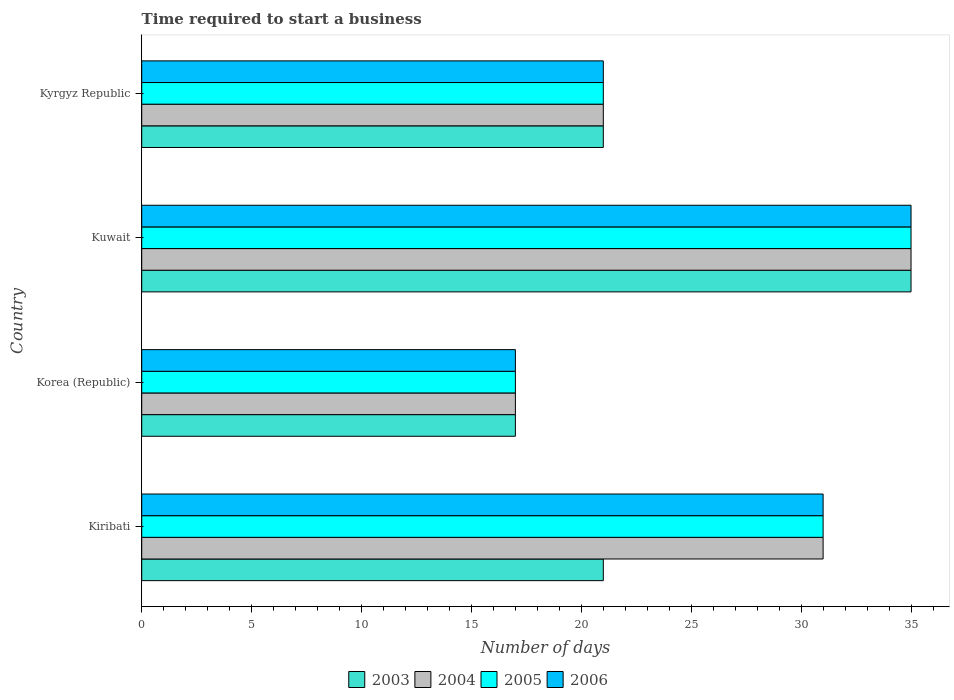How many different coloured bars are there?
Give a very brief answer. 4. In how many cases, is the number of bars for a given country not equal to the number of legend labels?
Make the answer very short. 0. What is the number of days required to start a business in 2004 in Korea (Republic)?
Offer a terse response. 17. Across all countries, what is the minimum number of days required to start a business in 2005?
Provide a succinct answer. 17. In which country was the number of days required to start a business in 2003 maximum?
Your response must be concise. Kuwait. In which country was the number of days required to start a business in 2005 minimum?
Your response must be concise. Korea (Republic). What is the total number of days required to start a business in 2003 in the graph?
Make the answer very short. 94. What is the average number of days required to start a business in 2004 per country?
Keep it short and to the point. 26. What is the difference between the number of days required to start a business in 2004 and number of days required to start a business in 2005 in Kyrgyz Republic?
Offer a terse response. 0. In how many countries, is the number of days required to start a business in 2003 greater than 9 days?
Your response must be concise. 4. What is the ratio of the number of days required to start a business in 2004 in Kiribati to that in Korea (Republic)?
Offer a very short reply. 1.82. What is the difference between the highest and the lowest number of days required to start a business in 2003?
Keep it short and to the point. 18. In how many countries, is the number of days required to start a business in 2005 greater than the average number of days required to start a business in 2005 taken over all countries?
Your answer should be very brief. 2. What does the 2nd bar from the top in Kiribati represents?
Offer a very short reply. 2005. What does the 2nd bar from the bottom in Korea (Republic) represents?
Provide a succinct answer. 2004. How many bars are there?
Your answer should be very brief. 16. How many countries are there in the graph?
Provide a short and direct response. 4. What is the difference between two consecutive major ticks on the X-axis?
Provide a short and direct response. 5. Does the graph contain grids?
Your response must be concise. No. What is the title of the graph?
Give a very brief answer. Time required to start a business. What is the label or title of the X-axis?
Your answer should be compact. Number of days. What is the label or title of the Y-axis?
Give a very brief answer. Country. What is the Number of days of 2004 in Kiribati?
Give a very brief answer. 31. What is the Number of days of 2005 in Kiribati?
Provide a short and direct response. 31. What is the Number of days of 2006 in Kiribati?
Provide a short and direct response. 31. What is the Number of days of 2004 in Korea (Republic)?
Your response must be concise. 17. What is the Number of days of 2006 in Korea (Republic)?
Provide a succinct answer. 17. What is the Number of days in 2003 in Kuwait?
Provide a short and direct response. 35. What is the Number of days in 2005 in Kuwait?
Make the answer very short. 35. What is the Number of days of 2004 in Kyrgyz Republic?
Keep it short and to the point. 21. What is the Number of days of 2006 in Kyrgyz Republic?
Ensure brevity in your answer.  21. Across all countries, what is the maximum Number of days in 2003?
Provide a succinct answer. 35. Across all countries, what is the maximum Number of days in 2005?
Make the answer very short. 35. Across all countries, what is the maximum Number of days of 2006?
Provide a succinct answer. 35. Across all countries, what is the minimum Number of days in 2004?
Offer a very short reply. 17. What is the total Number of days in 2003 in the graph?
Ensure brevity in your answer.  94. What is the total Number of days of 2004 in the graph?
Keep it short and to the point. 104. What is the total Number of days of 2005 in the graph?
Ensure brevity in your answer.  104. What is the total Number of days of 2006 in the graph?
Your answer should be compact. 104. What is the difference between the Number of days of 2005 in Kiribati and that in Korea (Republic)?
Make the answer very short. 14. What is the difference between the Number of days in 2006 in Kiribati and that in Korea (Republic)?
Your answer should be very brief. 14. What is the difference between the Number of days in 2003 in Kiribati and that in Kuwait?
Provide a succinct answer. -14. What is the difference between the Number of days in 2005 in Kiribati and that in Kuwait?
Keep it short and to the point. -4. What is the difference between the Number of days of 2006 in Kiribati and that in Kuwait?
Ensure brevity in your answer.  -4. What is the difference between the Number of days of 2003 in Kiribati and that in Kyrgyz Republic?
Provide a short and direct response. 0. What is the difference between the Number of days of 2004 in Kiribati and that in Kyrgyz Republic?
Your answer should be compact. 10. What is the difference between the Number of days in 2003 in Korea (Republic) and that in Kuwait?
Give a very brief answer. -18. What is the difference between the Number of days in 2004 in Korea (Republic) and that in Kuwait?
Your response must be concise. -18. What is the difference between the Number of days in 2005 in Korea (Republic) and that in Kuwait?
Ensure brevity in your answer.  -18. What is the difference between the Number of days in 2006 in Korea (Republic) and that in Kuwait?
Your answer should be compact. -18. What is the difference between the Number of days of 2003 in Korea (Republic) and that in Kyrgyz Republic?
Make the answer very short. -4. What is the difference between the Number of days in 2004 in Korea (Republic) and that in Kyrgyz Republic?
Provide a short and direct response. -4. What is the difference between the Number of days in 2005 in Korea (Republic) and that in Kyrgyz Republic?
Offer a very short reply. -4. What is the difference between the Number of days of 2004 in Kuwait and that in Kyrgyz Republic?
Make the answer very short. 14. What is the difference between the Number of days in 2004 in Kiribati and the Number of days in 2006 in Korea (Republic)?
Offer a very short reply. 14. What is the difference between the Number of days in 2005 in Kiribati and the Number of days in 2006 in Korea (Republic)?
Give a very brief answer. 14. What is the difference between the Number of days of 2003 in Kiribati and the Number of days of 2005 in Kuwait?
Your answer should be compact. -14. What is the difference between the Number of days of 2003 in Kiribati and the Number of days of 2006 in Kuwait?
Provide a succinct answer. -14. What is the difference between the Number of days in 2004 in Kiribati and the Number of days in 2005 in Kuwait?
Give a very brief answer. -4. What is the difference between the Number of days of 2003 in Kiribati and the Number of days of 2005 in Kyrgyz Republic?
Ensure brevity in your answer.  0. What is the difference between the Number of days of 2004 in Kiribati and the Number of days of 2006 in Kyrgyz Republic?
Keep it short and to the point. 10. What is the difference between the Number of days in 2005 in Kiribati and the Number of days in 2006 in Kyrgyz Republic?
Make the answer very short. 10. What is the difference between the Number of days of 2003 in Korea (Republic) and the Number of days of 2004 in Kuwait?
Provide a short and direct response. -18. What is the difference between the Number of days in 2003 in Korea (Republic) and the Number of days in 2005 in Kuwait?
Keep it short and to the point. -18. What is the difference between the Number of days in 2004 in Korea (Republic) and the Number of days in 2005 in Kuwait?
Provide a succinct answer. -18. What is the difference between the Number of days in 2005 in Korea (Republic) and the Number of days in 2006 in Kuwait?
Offer a very short reply. -18. What is the difference between the Number of days of 2003 in Korea (Republic) and the Number of days of 2004 in Kyrgyz Republic?
Offer a terse response. -4. What is the difference between the Number of days of 2003 in Korea (Republic) and the Number of days of 2005 in Kyrgyz Republic?
Keep it short and to the point. -4. What is the difference between the Number of days in 2004 in Korea (Republic) and the Number of days in 2005 in Kyrgyz Republic?
Offer a very short reply. -4. What is the difference between the Number of days of 2005 in Korea (Republic) and the Number of days of 2006 in Kyrgyz Republic?
Your answer should be compact. -4. What is the difference between the Number of days of 2003 in Kuwait and the Number of days of 2005 in Kyrgyz Republic?
Give a very brief answer. 14. What is the difference between the Number of days in 2004 in Kuwait and the Number of days in 2005 in Kyrgyz Republic?
Give a very brief answer. 14. What is the difference between the Number of days in 2005 in Kuwait and the Number of days in 2006 in Kyrgyz Republic?
Provide a short and direct response. 14. What is the average Number of days in 2003 per country?
Your response must be concise. 23.5. What is the average Number of days of 2006 per country?
Provide a short and direct response. 26. What is the difference between the Number of days in 2003 and Number of days in 2004 in Kiribati?
Give a very brief answer. -10. What is the difference between the Number of days of 2003 and Number of days of 2005 in Kiribati?
Provide a succinct answer. -10. What is the difference between the Number of days of 2003 and Number of days of 2006 in Kiribati?
Offer a very short reply. -10. What is the difference between the Number of days in 2004 and Number of days in 2005 in Kiribati?
Provide a succinct answer. 0. What is the difference between the Number of days in 2004 and Number of days in 2006 in Kiribati?
Your answer should be compact. 0. What is the difference between the Number of days in 2005 and Number of days in 2006 in Kiribati?
Give a very brief answer. 0. What is the difference between the Number of days in 2003 and Number of days in 2004 in Korea (Republic)?
Ensure brevity in your answer.  0. What is the difference between the Number of days of 2003 and Number of days of 2005 in Korea (Republic)?
Make the answer very short. 0. What is the difference between the Number of days of 2003 and Number of days of 2006 in Korea (Republic)?
Provide a succinct answer. 0. What is the difference between the Number of days of 2005 and Number of days of 2006 in Korea (Republic)?
Your answer should be very brief. 0. What is the difference between the Number of days of 2003 and Number of days of 2004 in Kuwait?
Provide a succinct answer. 0. What is the difference between the Number of days of 2003 and Number of days of 2006 in Kuwait?
Your answer should be very brief. 0. What is the difference between the Number of days of 2004 and Number of days of 2006 in Kuwait?
Keep it short and to the point. 0. What is the difference between the Number of days of 2003 and Number of days of 2004 in Kyrgyz Republic?
Keep it short and to the point. 0. What is the difference between the Number of days in 2004 and Number of days in 2006 in Kyrgyz Republic?
Provide a short and direct response. 0. What is the difference between the Number of days of 2005 and Number of days of 2006 in Kyrgyz Republic?
Offer a terse response. 0. What is the ratio of the Number of days of 2003 in Kiribati to that in Korea (Republic)?
Make the answer very short. 1.24. What is the ratio of the Number of days in 2004 in Kiribati to that in Korea (Republic)?
Ensure brevity in your answer.  1.82. What is the ratio of the Number of days in 2005 in Kiribati to that in Korea (Republic)?
Ensure brevity in your answer.  1.82. What is the ratio of the Number of days of 2006 in Kiribati to that in Korea (Republic)?
Ensure brevity in your answer.  1.82. What is the ratio of the Number of days in 2003 in Kiribati to that in Kuwait?
Your answer should be very brief. 0.6. What is the ratio of the Number of days of 2004 in Kiribati to that in Kuwait?
Offer a terse response. 0.89. What is the ratio of the Number of days in 2005 in Kiribati to that in Kuwait?
Keep it short and to the point. 0.89. What is the ratio of the Number of days of 2006 in Kiribati to that in Kuwait?
Provide a short and direct response. 0.89. What is the ratio of the Number of days of 2003 in Kiribati to that in Kyrgyz Republic?
Ensure brevity in your answer.  1. What is the ratio of the Number of days in 2004 in Kiribati to that in Kyrgyz Republic?
Provide a succinct answer. 1.48. What is the ratio of the Number of days in 2005 in Kiribati to that in Kyrgyz Republic?
Provide a short and direct response. 1.48. What is the ratio of the Number of days in 2006 in Kiribati to that in Kyrgyz Republic?
Your response must be concise. 1.48. What is the ratio of the Number of days in 2003 in Korea (Republic) to that in Kuwait?
Offer a terse response. 0.49. What is the ratio of the Number of days in 2004 in Korea (Republic) to that in Kuwait?
Give a very brief answer. 0.49. What is the ratio of the Number of days of 2005 in Korea (Republic) to that in Kuwait?
Provide a succinct answer. 0.49. What is the ratio of the Number of days in 2006 in Korea (Republic) to that in Kuwait?
Keep it short and to the point. 0.49. What is the ratio of the Number of days of 2003 in Korea (Republic) to that in Kyrgyz Republic?
Your response must be concise. 0.81. What is the ratio of the Number of days of 2004 in Korea (Republic) to that in Kyrgyz Republic?
Your answer should be very brief. 0.81. What is the ratio of the Number of days in 2005 in Korea (Republic) to that in Kyrgyz Republic?
Give a very brief answer. 0.81. What is the ratio of the Number of days of 2006 in Korea (Republic) to that in Kyrgyz Republic?
Provide a short and direct response. 0.81. What is the ratio of the Number of days in 2006 in Kuwait to that in Kyrgyz Republic?
Provide a succinct answer. 1.67. What is the difference between the highest and the second highest Number of days of 2006?
Make the answer very short. 4. What is the difference between the highest and the lowest Number of days of 2003?
Provide a short and direct response. 18. What is the difference between the highest and the lowest Number of days of 2004?
Give a very brief answer. 18. What is the difference between the highest and the lowest Number of days of 2006?
Offer a terse response. 18. 